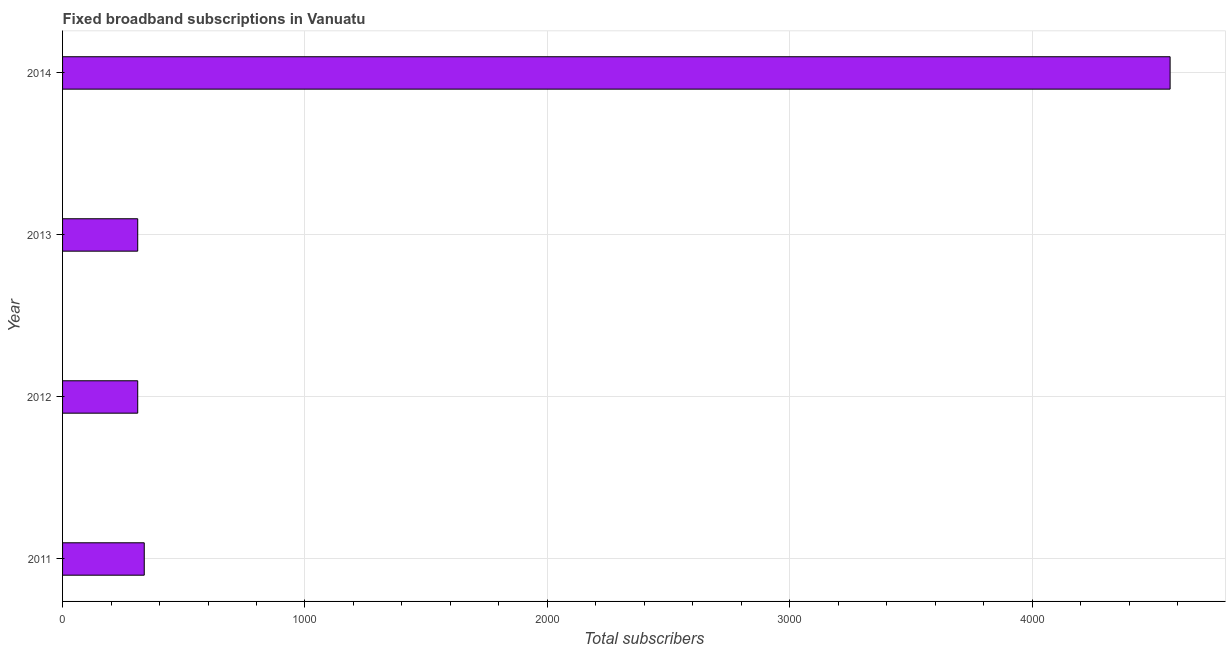Does the graph contain any zero values?
Give a very brief answer. No. What is the title of the graph?
Provide a short and direct response. Fixed broadband subscriptions in Vanuatu. What is the label or title of the X-axis?
Give a very brief answer. Total subscribers. What is the total number of fixed broadband subscriptions in 2011?
Your answer should be compact. 337. Across all years, what is the maximum total number of fixed broadband subscriptions?
Provide a short and direct response. 4569. Across all years, what is the minimum total number of fixed broadband subscriptions?
Your response must be concise. 310. What is the sum of the total number of fixed broadband subscriptions?
Provide a succinct answer. 5526. What is the difference between the total number of fixed broadband subscriptions in 2013 and 2014?
Give a very brief answer. -4259. What is the average total number of fixed broadband subscriptions per year?
Your answer should be very brief. 1381. What is the median total number of fixed broadband subscriptions?
Offer a terse response. 323.5. Do a majority of the years between 2013 and 2012 (inclusive) have total number of fixed broadband subscriptions greater than 800 ?
Ensure brevity in your answer.  No. What is the ratio of the total number of fixed broadband subscriptions in 2011 to that in 2013?
Offer a terse response. 1.09. Is the total number of fixed broadband subscriptions in 2011 less than that in 2013?
Provide a short and direct response. No. Is the difference between the total number of fixed broadband subscriptions in 2011 and 2014 greater than the difference between any two years?
Your answer should be very brief. No. What is the difference between the highest and the second highest total number of fixed broadband subscriptions?
Offer a terse response. 4232. Is the sum of the total number of fixed broadband subscriptions in 2011 and 2013 greater than the maximum total number of fixed broadband subscriptions across all years?
Your answer should be compact. No. What is the difference between the highest and the lowest total number of fixed broadband subscriptions?
Keep it short and to the point. 4259. How many years are there in the graph?
Offer a very short reply. 4. Are the values on the major ticks of X-axis written in scientific E-notation?
Keep it short and to the point. No. What is the Total subscribers in 2011?
Offer a very short reply. 337. What is the Total subscribers in 2012?
Ensure brevity in your answer.  310. What is the Total subscribers in 2013?
Offer a very short reply. 310. What is the Total subscribers in 2014?
Offer a very short reply. 4569. What is the difference between the Total subscribers in 2011 and 2013?
Keep it short and to the point. 27. What is the difference between the Total subscribers in 2011 and 2014?
Make the answer very short. -4232. What is the difference between the Total subscribers in 2012 and 2014?
Provide a short and direct response. -4259. What is the difference between the Total subscribers in 2013 and 2014?
Offer a very short reply. -4259. What is the ratio of the Total subscribers in 2011 to that in 2012?
Your response must be concise. 1.09. What is the ratio of the Total subscribers in 2011 to that in 2013?
Ensure brevity in your answer.  1.09. What is the ratio of the Total subscribers in 2011 to that in 2014?
Provide a short and direct response. 0.07. What is the ratio of the Total subscribers in 2012 to that in 2014?
Your answer should be compact. 0.07. What is the ratio of the Total subscribers in 2013 to that in 2014?
Make the answer very short. 0.07. 